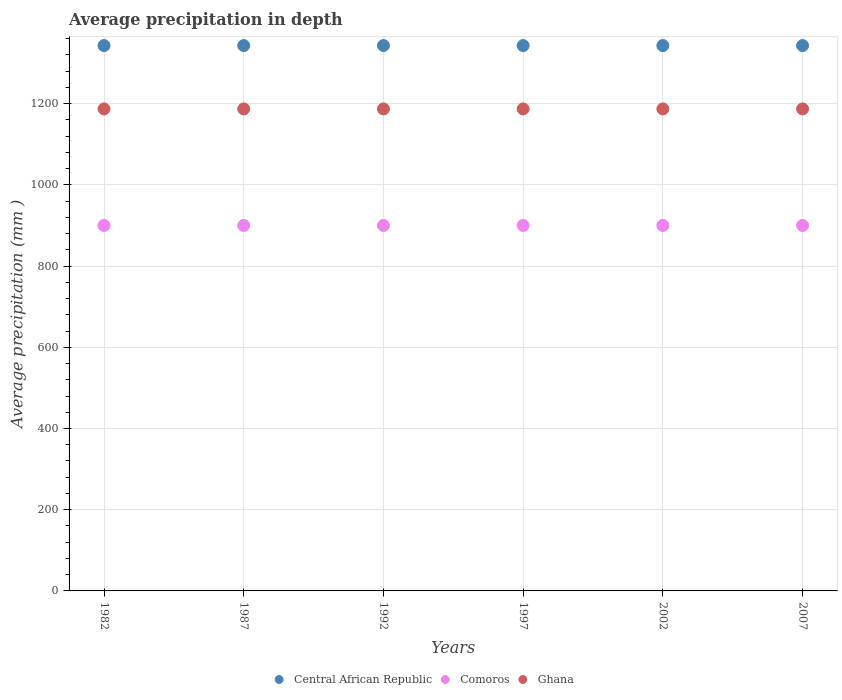What is the average precipitation in Ghana in 1997?
Offer a terse response. 1187. Across all years, what is the maximum average precipitation in Ghana?
Provide a succinct answer. 1187. Across all years, what is the minimum average precipitation in Central African Republic?
Offer a very short reply. 1343. In which year was the average precipitation in Ghana maximum?
Your answer should be compact. 1982. In which year was the average precipitation in Ghana minimum?
Your answer should be very brief. 1982. What is the total average precipitation in Comoros in the graph?
Give a very brief answer. 5400. What is the difference between the average precipitation in Central African Republic in 1997 and the average precipitation in Comoros in 2007?
Your response must be concise. 443. What is the average average precipitation in Comoros per year?
Your response must be concise. 900. In the year 2007, what is the difference between the average precipitation in Central African Republic and average precipitation in Ghana?
Keep it short and to the point. 156. What is the ratio of the average precipitation in Comoros in 1982 to that in 2007?
Ensure brevity in your answer.  1. Is the average precipitation in Central African Republic in 1987 less than that in 2002?
Offer a very short reply. No. Is the difference between the average precipitation in Central African Republic in 1997 and 2002 greater than the difference between the average precipitation in Ghana in 1997 and 2002?
Provide a short and direct response. No. What is the difference between the highest and the second highest average precipitation in Comoros?
Offer a very short reply. 0. What is the difference between the highest and the lowest average precipitation in Ghana?
Ensure brevity in your answer.  0. Is the sum of the average precipitation in Ghana in 1997 and 2002 greater than the maximum average precipitation in Comoros across all years?
Give a very brief answer. Yes. Is the average precipitation in Ghana strictly greater than the average precipitation in Comoros over the years?
Provide a short and direct response. Yes. Is the average precipitation in Central African Republic strictly less than the average precipitation in Ghana over the years?
Keep it short and to the point. No. How many dotlines are there?
Your response must be concise. 3. What is the difference between two consecutive major ticks on the Y-axis?
Offer a very short reply. 200. Are the values on the major ticks of Y-axis written in scientific E-notation?
Offer a terse response. No. Where does the legend appear in the graph?
Make the answer very short. Bottom center. How are the legend labels stacked?
Your answer should be compact. Horizontal. What is the title of the graph?
Give a very brief answer. Average precipitation in depth. Does "Middle East & North Africa (all income levels)" appear as one of the legend labels in the graph?
Provide a succinct answer. No. What is the label or title of the Y-axis?
Provide a succinct answer. Average precipitation (mm ). What is the Average precipitation (mm ) in Central African Republic in 1982?
Provide a short and direct response. 1343. What is the Average precipitation (mm ) of Comoros in 1982?
Provide a short and direct response. 900. What is the Average precipitation (mm ) in Ghana in 1982?
Your response must be concise. 1187. What is the Average precipitation (mm ) in Central African Republic in 1987?
Ensure brevity in your answer.  1343. What is the Average precipitation (mm ) in Comoros in 1987?
Provide a short and direct response. 900. What is the Average precipitation (mm ) in Ghana in 1987?
Provide a short and direct response. 1187. What is the Average precipitation (mm ) in Central African Republic in 1992?
Your answer should be compact. 1343. What is the Average precipitation (mm ) of Comoros in 1992?
Keep it short and to the point. 900. What is the Average precipitation (mm ) in Ghana in 1992?
Your response must be concise. 1187. What is the Average precipitation (mm ) of Central African Republic in 1997?
Offer a very short reply. 1343. What is the Average precipitation (mm ) in Comoros in 1997?
Your answer should be compact. 900. What is the Average precipitation (mm ) of Ghana in 1997?
Provide a short and direct response. 1187. What is the Average precipitation (mm ) in Central African Republic in 2002?
Provide a succinct answer. 1343. What is the Average precipitation (mm ) in Comoros in 2002?
Provide a short and direct response. 900. What is the Average precipitation (mm ) of Ghana in 2002?
Make the answer very short. 1187. What is the Average precipitation (mm ) in Central African Republic in 2007?
Provide a short and direct response. 1343. What is the Average precipitation (mm ) of Comoros in 2007?
Provide a succinct answer. 900. What is the Average precipitation (mm ) of Ghana in 2007?
Offer a terse response. 1187. Across all years, what is the maximum Average precipitation (mm ) of Central African Republic?
Offer a terse response. 1343. Across all years, what is the maximum Average precipitation (mm ) in Comoros?
Offer a terse response. 900. Across all years, what is the maximum Average precipitation (mm ) of Ghana?
Offer a terse response. 1187. Across all years, what is the minimum Average precipitation (mm ) of Central African Republic?
Provide a short and direct response. 1343. Across all years, what is the minimum Average precipitation (mm ) in Comoros?
Keep it short and to the point. 900. Across all years, what is the minimum Average precipitation (mm ) in Ghana?
Provide a short and direct response. 1187. What is the total Average precipitation (mm ) of Central African Republic in the graph?
Give a very brief answer. 8058. What is the total Average precipitation (mm ) in Comoros in the graph?
Provide a short and direct response. 5400. What is the total Average precipitation (mm ) in Ghana in the graph?
Offer a terse response. 7122. What is the difference between the Average precipitation (mm ) of Ghana in 1982 and that in 1987?
Keep it short and to the point. 0. What is the difference between the Average precipitation (mm ) in Central African Republic in 1982 and that in 1992?
Keep it short and to the point. 0. What is the difference between the Average precipitation (mm ) of Comoros in 1982 and that in 1997?
Keep it short and to the point. 0. What is the difference between the Average precipitation (mm ) of Ghana in 1982 and that in 2007?
Offer a very short reply. 0. What is the difference between the Average precipitation (mm ) of Comoros in 1987 and that in 1992?
Your answer should be very brief. 0. What is the difference between the Average precipitation (mm ) in Ghana in 1987 and that in 1992?
Your answer should be compact. 0. What is the difference between the Average precipitation (mm ) in Central African Republic in 1987 and that in 1997?
Give a very brief answer. 0. What is the difference between the Average precipitation (mm ) of Ghana in 1987 and that in 1997?
Offer a very short reply. 0. What is the difference between the Average precipitation (mm ) in Ghana in 1987 and that in 2002?
Offer a terse response. 0. What is the difference between the Average precipitation (mm ) of Ghana in 1987 and that in 2007?
Make the answer very short. 0. What is the difference between the Average precipitation (mm ) of Comoros in 1992 and that in 1997?
Ensure brevity in your answer.  0. What is the difference between the Average precipitation (mm ) in Ghana in 1992 and that in 1997?
Give a very brief answer. 0. What is the difference between the Average precipitation (mm ) of Comoros in 1992 and that in 2002?
Provide a succinct answer. 0. What is the difference between the Average precipitation (mm ) of Ghana in 1992 and that in 2002?
Ensure brevity in your answer.  0. What is the difference between the Average precipitation (mm ) of Ghana in 1992 and that in 2007?
Your answer should be very brief. 0. What is the difference between the Average precipitation (mm ) in Comoros in 1997 and that in 2002?
Ensure brevity in your answer.  0. What is the difference between the Average precipitation (mm ) in Ghana in 1997 and that in 2002?
Offer a very short reply. 0. What is the difference between the Average precipitation (mm ) of Ghana in 1997 and that in 2007?
Your response must be concise. 0. What is the difference between the Average precipitation (mm ) in Ghana in 2002 and that in 2007?
Provide a short and direct response. 0. What is the difference between the Average precipitation (mm ) in Central African Republic in 1982 and the Average precipitation (mm ) in Comoros in 1987?
Keep it short and to the point. 443. What is the difference between the Average precipitation (mm ) in Central African Republic in 1982 and the Average precipitation (mm ) in Ghana in 1987?
Your answer should be very brief. 156. What is the difference between the Average precipitation (mm ) in Comoros in 1982 and the Average precipitation (mm ) in Ghana in 1987?
Give a very brief answer. -287. What is the difference between the Average precipitation (mm ) of Central African Republic in 1982 and the Average precipitation (mm ) of Comoros in 1992?
Offer a terse response. 443. What is the difference between the Average precipitation (mm ) in Central African Republic in 1982 and the Average precipitation (mm ) in Ghana in 1992?
Provide a short and direct response. 156. What is the difference between the Average precipitation (mm ) of Comoros in 1982 and the Average precipitation (mm ) of Ghana in 1992?
Make the answer very short. -287. What is the difference between the Average precipitation (mm ) in Central African Republic in 1982 and the Average precipitation (mm ) in Comoros in 1997?
Ensure brevity in your answer.  443. What is the difference between the Average precipitation (mm ) in Central African Republic in 1982 and the Average precipitation (mm ) in Ghana in 1997?
Offer a very short reply. 156. What is the difference between the Average precipitation (mm ) of Comoros in 1982 and the Average precipitation (mm ) of Ghana in 1997?
Provide a succinct answer. -287. What is the difference between the Average precipitation (mm ) in Central African Republic in 1982 and the Average precipitation (mm ) in Comoros in 2002?
Give a very brief answer. 443. What is the difference between the Average precipitation (mm ) of Central African Republic in 1982 and the Average precipitation (mm ) of Ghana in 2002?
Keep it short and to the point. 156. What is the difference between the Average precipitation (mm ) in Comoros in 1982 and the Average precipitation (mm ) in Ghana in 2002?
Make the answer very short. -287. What is the difference between the Average precipitation (mm ) in Central African Republic in 1982 and the Average precipitation (mm ) in Comoros in 2007?
Your response must be concise. 443. What is the difference between the Average precipitation (mm ) in Central African Republic in 1982 and the Average precipitation (mm ) in Ghana in 2007?
Your answer should be very brief. 156. What is the difference between the Average precipitation (mm ) of Comoros in 1982 and the Average precipitation (mm ) of Ghana in 2007?
Give a very brief answer. -287. What is the difference between the Average precipitation (mm ) in Central African Republic in 1987 and the Average precipitation (mm ) in Comoros in 1992?
Give a very brief answer. 443. What is the difference between the Average precipitation (mm ) in Central African Republic in 1987 and the Average precipitation (mm ) in Ghana in 1992?
Give a very brief answer. 156. What is the difference between the Average precipitation (mm ) of Comoros in 1987 and the Average precipitation (mm ) of Ghana in 1992?
Make the answer very short. -287. What is the difference between the Average precipitation (mm ) in Central African Republic in 1987 and the Average precipitation (mm ) in Comoros in 1997?
Ensure brevity in your answer.  443. What is the difference between the Average precipitation (mm ) in Central African Republic in 1987 and the Average precipitation (mm ) in Ghana in 1997?
Ensure brevity in your answer.  156. What is the difference between the Average precipitation (mm ) in Comoros in 1987 and the Average precipitation (mm ) in Ghana in 1997?
Offer a very short reply. -287. What is the difference between the Average precipitation (mm ) in Central African Republic in 1987 and the Average precipitation (mm ) in Comoros in 2002?
Keep it short and to the point. 443. What is the difference between the Average precipitation (mm ) in Central African Republic in 1987 and the Average precipitation (mm ) in Ghana in 2002?
Provide a succinct answer. 156. What is the difference between the Average precipitation (mm ) in Comoros in 1987 and the Average precipitation (mm ) in Ghana in 2002?
Provide a succinct answer. -287. What is the difference between the Average precipitation (mm ) in Central African Republic in 1987 and the Average precipitation (mm ) in Comoros in 2007?
Provide a short and direct response. 443. What is the difference between the Average precipitation (mm ) of Central African Republic in 1987 and the Average precipitation (mm ) of Ghana in 2007?
Keep it short and to the point. 156. What is the difference between the Average precipitation (mm ) in Comoros in 1987 and the Average precipitation (mm ) in Ghana in 2007?
Offer a very short reply. -287. What is the difference between the Average precipitation (mm ) in Central African Republic in 1992 and the Average precipitation (mm ) in Comoros in 1997?
Your response must be concise. 443. What is the difference between the Average precipitation (mm ) in Central African Republic in 1992 and the Average precipitation (mm ) in Ghana in 1997?
Offer a terse response. 156. What is the difference between the Average precipitation (mm ) of Comoros in 1992 and the Average precipitation (mm ) of Ghana in 1997?
Ensure brevity in your answer.  -287. What is the difference between the Average precipitation (mm ) in Central African Republic in 1992 and the Average precipitation (mm ) in Comoros in 2002?
Your response must be concise. 443. What is the difference between the Average precipitation (mm ) of Central African Republic in 1992 and the Average precipitation (mm ) of Ghana in 2002?
Offer a very short reply. 156. What is the difference between the Average precipitation (mm ) of Comoros in 1992 and the Average precipitation (mm ) of Ghana in 2002?
Provide a short and direct response. -287. What is the difference between the Average precipitation (mm ) of Central African Republic in 1992 and the Average precipitation (mm ) of Comoros in 2007?
Ensure brevity in your answer.  443. What is the difference between the Average precipitation (mm ) in Central African Republic in 1992 and the Average precipitation (mm ) in Ghana in 2007?
Give a very brief answer. 156. What is the difference between the Average precipitation (mm ) in Comoros in 1992 and the Average precipitation (mm ) in Ghana in 2007?
Give a very brief answer. -287. What is the difference between the Average precipitation (mm ) in Central African Republic in 1997 and the Average precipitation (mm ) in Comoros in 2002?
Offer a terse response. 443. What is the difference between the Average precipitation (mm ) of Central African Republic in 1997 and the Average precipitation (mm ) of Ghana in 2002?
Ensure brevity in your answer.  156. What is the difference between the Average precipitation (mm ) in Comoros in 1997 and the Average precipitation (mm ) in Ghana in 2002?
Provide a short and direct response. -287. What is the difference between the Average precipitation (mm ) of Central African Republic in 1997 and the Average precipitation (mm ) of Comoros in 2007?
Give a very brief answer. 443. What is the difference between the Average precipitation (mm ) of Central African Republic in 1997 and the Average precipitation (mm ) of Ghana in 2007?
Make the answer very short. 156. What is the difference between the Average precipitation (mm ) in Comoros in 1997 and the Average precipitation (mm ) in Ghana in 2007?
Keep it short and to the point. -287. What is the difference between the Average precipitation (mm ) of Central African Republic in 2002 and the Average precipitation (mm ) of Comoros in 2007?
Provide a succinct answer. 443. What is the difference between the Average precipitation (mm ) of Central African Republic in 2002 and the Average precipitation (mm ) of Ghana in 2007?
Offer a very short reply. 156. What is the difference between the Average precipitation (mm ) in Comoros in 2002 and the Average precipitation (mm ) in Ghana in 2007?
Provide a short and direct response. -287. What is the average Average precipitation (mm ) in Central African Republic per year?
Your answer should be very brief. 1343. What is the average Average precipitation (mm ) in Comoros per year?
Your answer should be compact. 900. What is the average Average precipitation (mm ) in Ghana per year?
Offer a terse response. 1187. In the year 1982, what is the difference between the Average precipitation (mm ) of Central African Republic and Average precipitation (mm ) of Comoros?
Offer a very short reply. 443. In the year 1982, what is the difference between the Average precipitation (mm ) of Central African Republic and Average precipitation (mm ) of Ghana?
Provide a short and direct response. 156. In the year 1982, what is the difference between the Average precipitation (mm ) in Comoros and Average precipitation (mm ) in Ghana?
Your answer should be compact. -287. In the year 1987, what is the difference between the Average precipitation (mm ) of Central African Republic and Average precipitation (mm ) of Comoros?
Give a very brief answer. 443. In the year 1987, what is the difference between the Average precipitation (mm ) in Central African Republic and Average precipitation (mm ) in Ghana?
Provide a succinct answer. 156. In the year 1987, what is the difference between the Average precipitation (mm ) in Comoros and Average precipitation (mm ) in Ghana?
Keep it short and to the point. -287. In the year 1992, what is the difference between the Average precipitation (mm ) of Central African Republic and Average precipitation (mm ) of Comoros?
Your answer should be very brief. 443. In the year 1992, what is the difference between the Average precipitation (mm ) in Central African Republic and Average precipitation (mm ) in Ghana?
Give a very brief answer. 156. In the year 1992, what is the difference between the Average precipitation (mm ) in Comoros and Average precipitation (mm ) in Ghana?
Offer a very short reply. -287. In the year 1997, what is the difference between the Average precipitation (mm ) of Central African Republic and Average precipitation (mm ) of Comoros?
Your answer should be compact. 443. In the year 1997, what is the difference between the Average precipitation (mm ) of Central African Republic and Average precipitation (mm ) of Ghana?
Provide a succinct answer. 156. In the year 1997, what is the difference between the Average precipitation (mm ) of Comoros and Average precipitation (mm ) of Ghana?
Provide a succinct answer. -287. In the year 2002, what is the difference between the Average precipitation (mm ) in Central African Republic and Average precipitation (mm ) in Comoros?
Give a very brief answer. 443. In the year 2002, what is the difference between the Average precipitation (mm ) of Central African Republic and Average precipitation (mm ) of Ghana?
Your answer should be very brief. 156. In the year 2002, what is the difference between the Average precipitation (mm ) in Comoros and Average precipitation (mm ) in Ghana?
Provide a short and direct response. -287. In the year 2007, what is the difference between the Average precipitation (mm ) of Central African Republic and Average precipitation (mm ) of Comoros?
Your answer should be very brief. 443. In the year 2007, what is the difference between the Average precipitation (mm ) in Central African Republic and Average precipitation (mm ) in Ghana?
Ensure brevity in your answer.  156. In the year 2007, what is the difference between the Average precipitation (mm ) of Comoros and Average precipitation (mm ) of Ghana?
Offer a very short reply. -287. What is the ratio of the Average precipitation (mm ) of Ghana in 1982 to that in 1987?
Ensure brevity in your answer.  1. What is the ratio of the Average precipitation (mm ) of Central African Republic in 1982 to that in 1992?
Offer a very short reply. 1. What is the ratio of the Average precipitation (mm ) in Comoros in 1982 to that in 1992?
Provide a short and direct response. 1. What is the ratio of the Average precipitation (mm ) of Ghana in 1982 to that in 1992?
Ensure brevity in your answer.  1. What is the ratio of the Average precipitation (mm ) of Comoros in 1982 to that in 1997?
Keep it short and to the point. 1. What is the ratio of the Average precipitation (mm ) of Central African Republic in 1982 to that in 2002?
Your answer should be compact. 1. What is the ratio of the Average precipitation (mm ) of Comoros in 1982 to that in 2002?
Keep it short and to the point. 1. What is the ratio of the Average precipitation (mm ) of Ghana in 1982 to that in 2002?
Provide a succinct answer. 1. What is the ratio of the Average precipitation (mm ) in Comoros in 1982 to that in 2007?
Provide a succinct answer. 1. What is the ratio of the Average precipitation (mm ) of Ghana in 1982 to that in 2007?
Make the answer very short. 1. What is the ratio of the Average precipitation (mm ) of Comoros in 1987 to that in 1992?
Make the answer very short. 1. What is the ratio of the Average precipitation (mm ) of Comoros in 1987 to that in 1997?
Give a very brief answer. 1. What is the ratio of the Average precipitation (mm ) in Central African Republic in 1987 to that in 2002?
Offer a very short reply. 1. What is the ratio of the Average precipitation (mm ) of Ghana in 1987 to that in 2002?
Keep it short and to the point. 1. What is the ratio of the Average precipitation (mm ) in Comoros in 1987 to that in 2007?
Offer a very short reply. 1. What is the ratio of the Average precipitation (mm ) of Ghana in 1987 to that in 2007?
Provide a succinct answer. 1. What is the ratio of the Average precipitation (mm ) of Ghana in 1992 to that in 1997?
Offer a very short reply. 1. What is the ratio of the Average precipitation (mm ) in Comoros in 1992 to that in 2002?
Make the answer very short. 1. What is the ratio of the Average precipitation (mm ) of Comoros in 1992 to that in 2007?
Offer a very short reply. 1. What is the ratio of the Average precipitation (mm ) in Central African Republic in 1997 to that in 2007?
Your response must be concise. 1. What is the ratio of the Average precipitation (mm ) in Comoros in 1997 to that in 2007?
Your response must be concise. 1. What is the ratio of the Average precipitation (mm ) in Comoros in 2002 to that in 2007?
Offer a very short reply. 1. What is the difference between the highest and the second highest Average precipitation (mm ) of Central African Republic?
Your answer should be very brief. 0. What is the difference between the highest and the second highest Average precipitation (mm ) of Comoros?
Provide a succinct answer. 0. What is the difference between the highest and the second highest Average precipitation (mm ) in Ghana?
Offer a very short reply. 0. What is the difference between the highest and the lowest Average precipitation (mm ) in Central African Republic?
Keep it short and to the point. 0. 